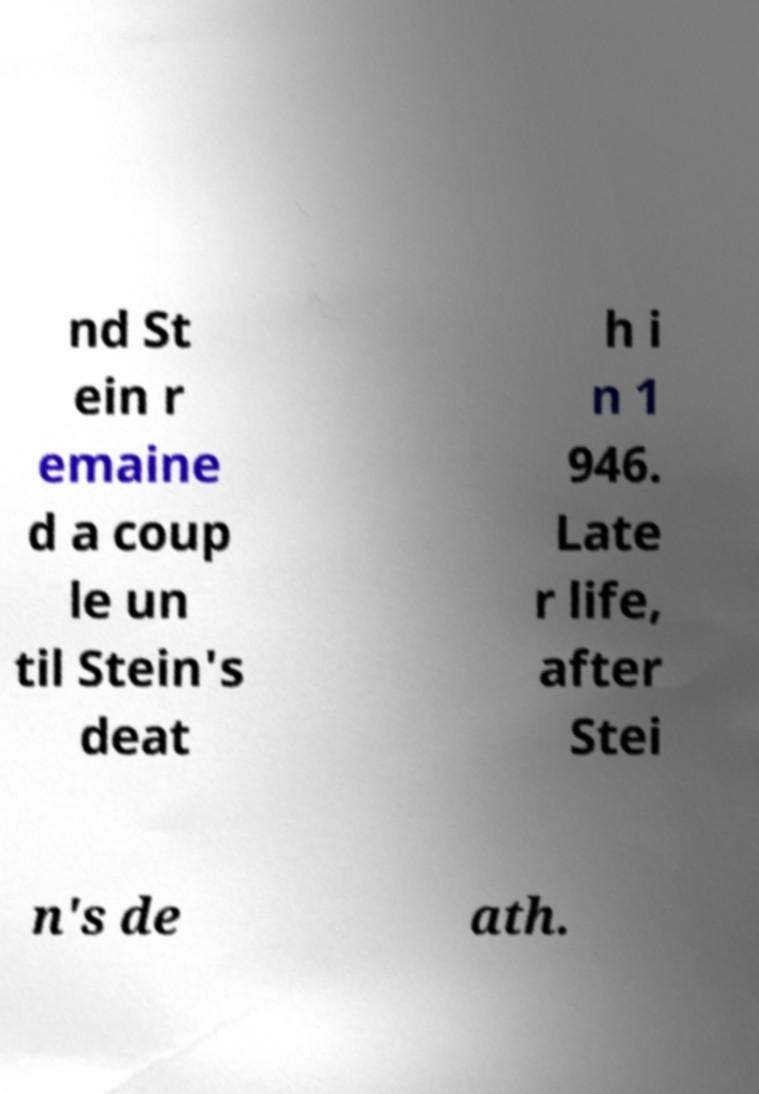Can you read and provide the text displayed in the image?This photo seems to have some interesting text. Can you extract and type it out for me? nd St ein r emaine d a coup le un til Stein's deat h i n 1 946. Late r life, after Stei n's de ath. 